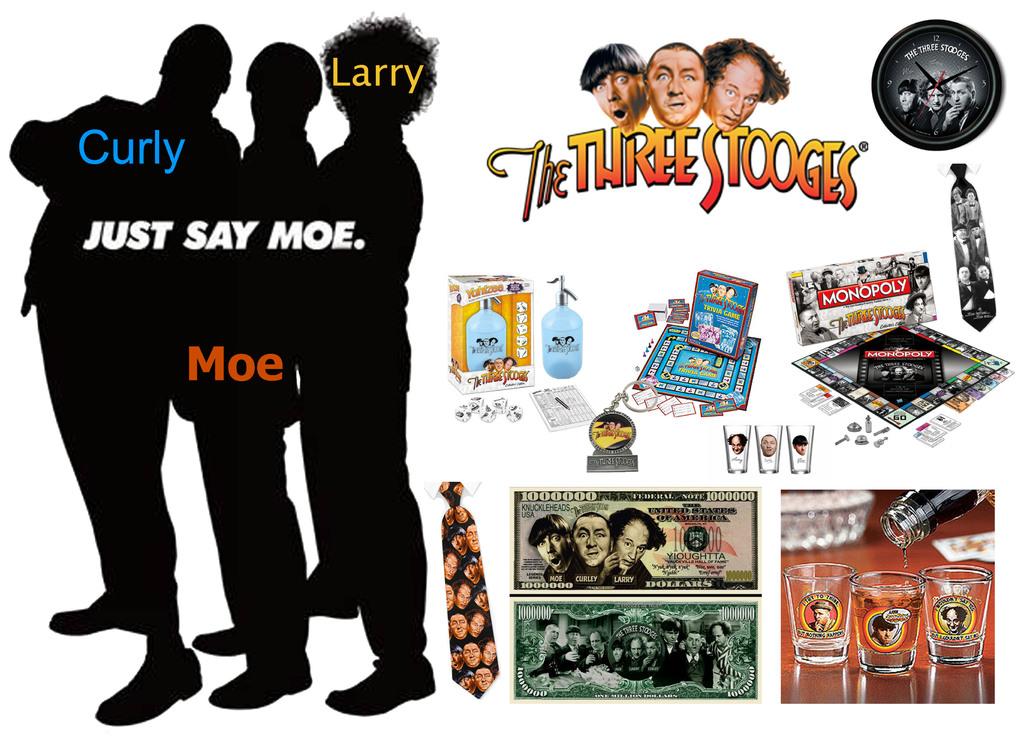What is the name of the movie?
Provide a succinct answer. The three stooges. 